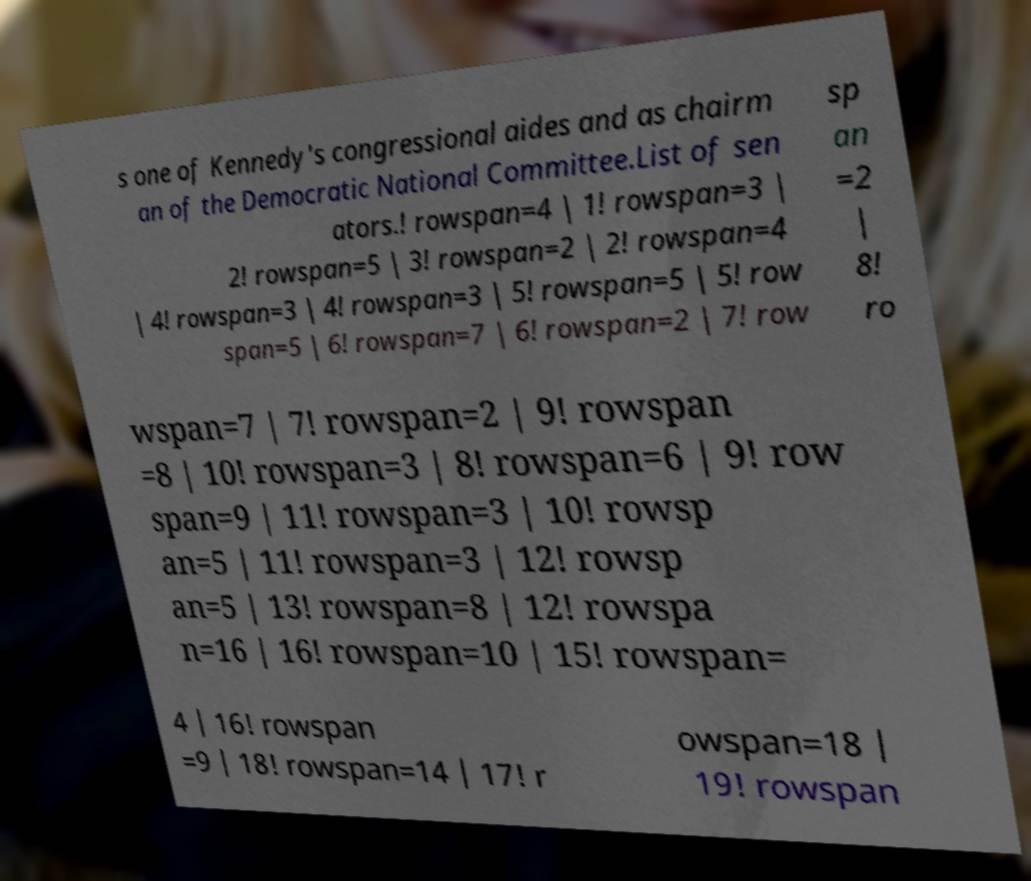Can you accurately transcribe the text from the provided image for me? s one of Kennedy's congressional aides and as chairm an of the Democratic National Committee.List of sen ators.! rowspan=4 | 1! rowspan=3 | 2! rowspan=5 | 3! rowspan=2 | 2! rowspan=4 | 4! rowspan=3 | 4! rowspan=3 | 5! rowspan=5 | 5! row span=5 | 6! rowspan=7 | 6! rowspan=2 | 7! row sp an =2 | 8! ro wspan=7 | 7! rowspan=2 | 9! rowspan =8 | 10! rowspan=3 | 8! rowspan=6 | 9! row span=9 | 11! rowspan=3 | 10! rowsp an=5 | 11! rowspan=3 | 12! rowsp an=5 | 13! rowspan=8 | 12! rowspa n=16 | 16! rowspan=10 | 15! rowspan= 4 | 16! rowspan =9 | 18! rowspan=14 | 17! r owspan=18 | 19! rowspan 